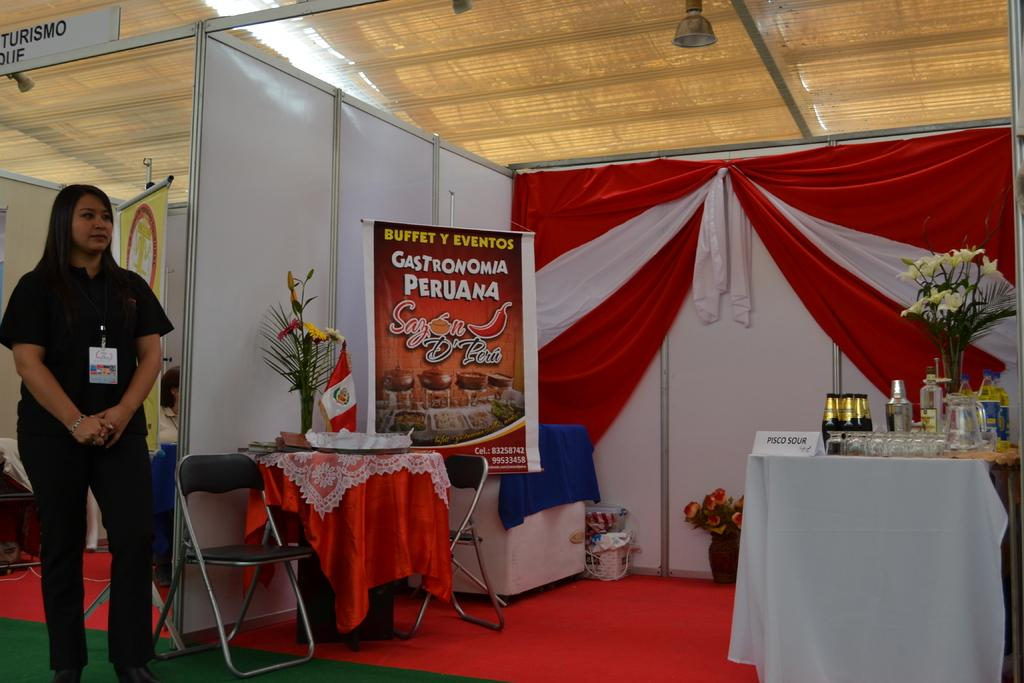What is the primary subject in the image? There is a woman standing in the image. Where is the woman standing? The woman is standing on the floor. What furniture is present in the image? There is a chair and a table in the image. What is on the table? There are objects on the table. What page of the book is the ghost reading in the image? There is no book or ghost present in the image. What color is the gold object on the table in the image? There is no gold object present in the image. 